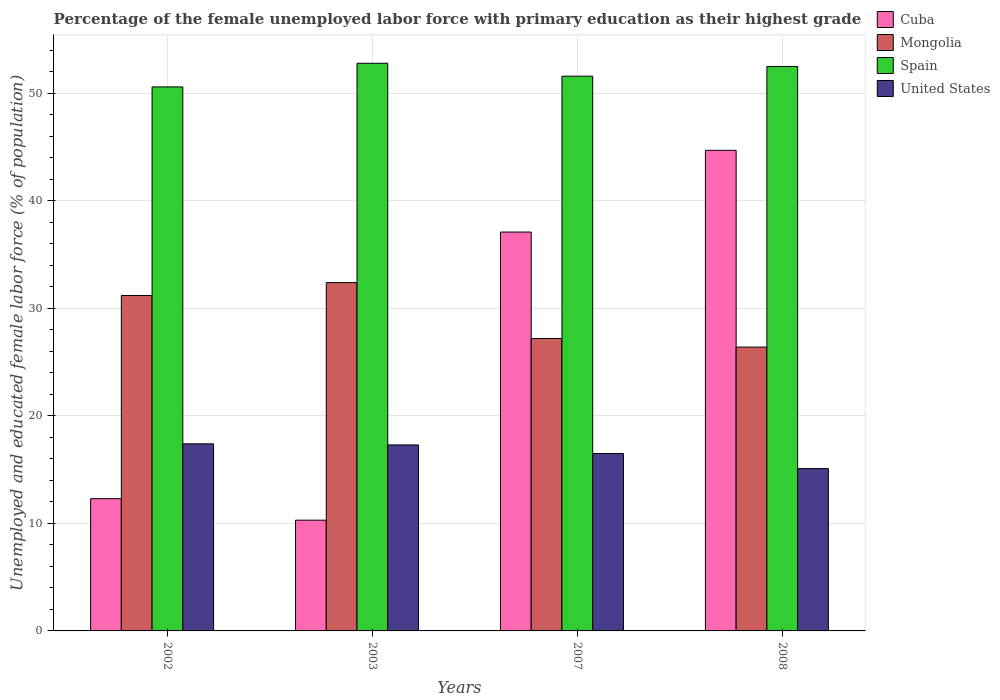How many different coloured bars are there?
Give a very brief answer. 4. How many bars are there on the 3rd tick from the left?
Offer a very short reply. 4. What is the label of the 1st group of bars from the left?
Provide a short and direct response. 2002. In how many cases, is the number of bars for a given year not equal to the number of legend labels?
Your answer should be compact. 0. What is the percentage of the unemployed female labor force with primary education in Spain in 2002?
Keep it short and to the point. 50.6. Across all years, what is the maximum percentage of the unemployed female labor force with primary education in Cuba?
Provide a succinct answer. 44.7. Across all years, what is the minimum percentage of the unemployed female labor force with primary education in Mongolia?
Give a very brief answer. 26.4. What is the total percentage of the unemployed female labor force with primary education in Mongolia in the graph?
Ensure brevity in your answer.  117.2. What is the difference between the percentage of the unemployed female labor force with primary education in United States in 2007 and that in 2008?
Ensure brevity in your answer.  1.4. What is the difference between the percentage of the unemployed female labor force with primary education in Mongolia in 2008 and the percentage of the unemployed female labor force with primary education in United States in 2007?
Make the answer very short. 9.9. What is the average percentage of the unemployed female labor force with primary education in United States per year?
Make the answer very short. 16.57. In the year 2002, what is the difference between the percentage of the unemployed female labor force with primary education in United States and percentage of the unemployed female labor force with primary education in Cuba?
Your response must be concise. 5.1. What is the ratio of the percentage of the unemployed female labor force with primary education in United States in 2002 to that in 2003?
Your response must be concise. 1.01. What is the difference between the highest and the second highest percentage of the unemployed female labor force with primary education in United States?
Offer a terse response. 0.1. What is the difference between the highest and the lowest percentage of the unemployed female labor force with primary education in Spain?
Your answer should be very brief. 2.2. In how many years, is the percentage of the unemployed female labor force with primary education in Spain greater than the average percentage of the unemployed female labor force with primary education in Spain taken over all years?
Keep it short and to the point. 2. What does the 3rd bar from the left in 2008 represents?
Give a very brief answer. Spain. Is it the case that in every year, the sum of the percentage of the unemployed female labor force with primary education in Spain and percentage of the unemployed female labor force with primary education in United States is greater than the percentage of the unemployed female labor force with primary education in Cuba?
Keep it short and to the point. Yes. Are all the bars in the graph horizontal?
Offer a terse response. No. What is the title of the graph?
Offer a terse response. Percentage of the female unemployed labor force with primary education as their highest grade. Does "Sub-Saharan Africa (developing only)" appear as one of the legend labels in the graph?
Offer a terse response. No. What is the label or title of the X-axis?
Give a very brief answer. Years. What is the label or title of the Y-axis?
Your answer should be very brief. Unemployed and educated female labor force (% of population). What is the Unemployed and educated female labor force (% of population) of Cuba in 2002?
Offer a terse response. 12.3. What is the Unemployed and educated female labor force (% of population) in Mongolia in 2002?
Offer a terse response. 31.2. What is the Unemployed and educated female labor force (% of population) in Spain in 2002?
Make the answer very short. 50.6. What is the Unemployed and educated female labor force (% of population) in United States in 2002?
Give a very brief answer. 17.4. What is the Unemployed and educated female labor force (% of population) of Cuba in 2003?
Offer a terse response. 10.3. What is the Unemployed and educated female labor force (% of population) in Mongolia in 2003?
Provide a succinct answer. 32.4. What is the Unemployed and educated female labor force (% of population) of Spain in 2003?
Ensure brevity in your answer.  52.8. What is the Unemployed and educated female labor force (% of population) of United States in 2003?
Provide a succinct answer. 17.3. What is the Unemployed and educated female labor force (% of population) of Cuba in 2007?
Provide a succinct answer. 37.1. What is the Unemployed and educated female labor force (% of population) in Mongolia in 2007?
Your answer should be very brief. 27.2. What is the Unemployed and educated female labor force (% of population) of Spain in 2007?
Offer a terse response. 51.6. What is the Unemployed and educated female labor force (% of population) in Cuba in 2008?
Offer a terse response. 44.7. What is the Unemployed and educated female labor force (% of population) of Mongolia in 2008?
Offer a very short reply. 26.4. What is the Unemployed and educated female labor force (% of population) of Spain in 2008?
Offer a terse response. 52.5. What is the Unemployed and educated female labor force (% of population) in United States in 2008?
Offer a very short reply. 15.1. Across all years, what is the maximum Unemployed and educated female labor force (% of population) of Cuba?
Your answer should be compact. 44.7. Across all years, what is the maximum Unemployed and educated female labor force (% of population) of Mongolia?
Provide a succinct answer. 32.4. Across all years, what is the maximum Unemployed and educated female labor force (% of population) in Spain?
Make the answer very short. 52.8. Across all years, what is the maximum Unemployed and educated female labor force (% of population) in United States?
Make the answer very short. 17.4. Across all years, what is the minimum Unemployed and educated female labor force (% of population) in Cuba?
Ensure brevity in your answer.  10.3. Across all years, what is the minimum Unemployed and educated female labor force (% of population) in Mongolia?
Make the answer very short. 26.4. Across all years, what is the minimum Unemployed and educated female labor force (% of population) in Spain?
Offer a very short reply. 50.6. Across all years, what is the minimum Unemployed and educated female labor force (% of population) of United States?
Offer a very short reply. 15.1. What is the total Unemployed and educated female labor force (% of population) of Cuba in the graph?
Keep it short and to the point. 104.4. What is the total Unemployed and educated female labor force (% of population) in Mongolia in the graph?
Your response must be concise. 117.2. What is the total Unemployed and educated female labor force (% of population) in Spain in the graph?
Your answer should be very brief. 207.5. What is the total Unemployed and educated female labor force (% of population) of United States in the graph?
Your answer should be compact. 66.3. What is the difference between the Unemployed and educated female labor force (% of population) of Mongolia in 2002 and that in 2003?
Offer a very short reply. -1.2. What is the difference between the Unemployed and educated female labor force (% of population) in Cuba in 2002 and that in 2007?
Your response must be concise. -24.8. What is the difference between the Unemployed and educated female labor force (% of population) in Mongolia in 2002 and that in 2007?
Your answer should be very brief. 4. What is the difference between the Unemployed and educated female labor force (% of population) of Spain in 2002 and that in 2007?
Ensure brevity in your answer.  -1. What is the difference between the Unemployed and educated female labor force (% of population) of United States in 2002 and that in 2007?
Your answer should be compact. 0.9. What is the difference between the Unemployed and educated female labor force (% of population) in Cuba in 2002 and that in 2008?
Your answer should be very brief. -32.4. What is the difference between the Unemployed and educated female labor force (% of population) in Spain in 2002 and that in 2008?
Keep it short and to the point. -1.9. What is the difference between the Unemployed and educated female labor force (% of population) in Cuba in 2003 and that in 2007?
Offer a terse response. -26.8. What is the difference between the Unemployed and educated female labor force (% of population) of Cuba in 2003 and that in 2008?
Make the answer very short. -34.4. What is the difference between the Unemployed and educated female labor force (% of population) of Mongolia in 2003 and that in 2008?
Offer a very short reply. 6. What is the difference between the Unemployed and educated female labor force (% of population) in Cuba in 2007 and that in 2008?
Keep it short and to the point. -7.6. What is the difference between the Unemployed and educated female labor force (% of population) in Mongolia in 2007 and that in 2008?
Your answer should be compact. 0.8. What is the difference between the Unemployed and educated female labor force (% of population) of Cuba in 2002 and the Unemployed and educated female labor force (% of population) of Mongolia in 2003?
Keep it short and to the point. -20.1. What is the difference between the Unemployed and educated female labor force (% of population) of Cuba in 2002 and the Unemployed and educated female labor force (% of population) of Spain in 2003?
Give a very brief answer. -40.5. What is the difference between the Unemployed and educated female labor force (% of population) of Mongolia in 2002 and the Unemployed and educated female labor force (% of population) of Spain in 2003?
Provide a succinct answer. -21.6. What is the difference between the Unemployed and educated female labor force (% of population) in Spain in 2002 and the Unemployed and educated female labor force (% of population) in United States in 2003?
Ensure brevity in your answer.  33.3. What is the difference between the Unemployed and educated female labor force (% of population) of Cuba in 2002 and the Unemployed and educated female labor force (% of population) of Mongolia in 2007?
Provide a short and direct response. -14.9. What is the difference between the Unemployed and educated female labor force (% of population) in Cuba in 2002 and the Unemployed and educated female labor force (% of population) in Spain in 2007?
Provide a succinct answer. -39.3. What is the difference between the Unemployed and educated female labor force (% of population) of Cuba in 2002 and the Unemployed and educated female labor force (% of population) of United States in 2007?
Ensure brevity in your answer.  -4.2. What is the difference between the Unemployed and educated female labor force (% of population) of Mongolia in 2002 and the Unemployed and educated female labor force (% of population) of Spain in 2007?
Keep it short and to the point. -20.4. What is the difference between the Unemployed and educated female labor force (% of population) of Spain in 2002 and the Unemployed and educated female labor force (% of population) of United States in 2007?
Offer a terse response. 34.1. What is the difference between the Unemployed and educated female labor force (% of population) in Cuba in 2002 and the Unemployed and educated female labor force (% of population) in Mongolia in 2008?
Your answer should be compact. -14.1. What is the difference between the Unemployed and educated female labor force (% of population) of Cuba in 2002 and the Unemployed and educated female labor force (% of population) of Spain in 2008?
Your response must be concise. -40.2. What is the difference between the Unemployed and educated female labor force (% of population) in Cuba in 2002 and the Unemployed and educated female labor force (% of population) in United States in 2008?
Your answer should be very brief. -2.8. What is the difference between the Unemployed and educated female labor force (% of population) of Mongolia in 2002 and the Unemployed and educated female labor force (% of population) of Spain in 2008?
Provide a succinct answer. -21.3. What is the difference between the Unemployed and educated female labor force (% of population) of Spain in 2002 and the Unemployed and educated female labor force (% of population) of United States in 2008?
Offer a very short reply. 35.5. What is the difference between the Unemployed and educated female labor force (% of population) in Cuba in 2003 and the Unemployed and educated female labor force (% of population) in Mongolia in 2007?
Offer a terse response. -16.9. What is the difference between the Unemployed and educated female labor force (% of population) of Cuba in 2003 and the Unemployed and educated female labor force (% of population) of Spain in 2007?
Provide a short and direct response. -41.3. What is the difference between the Unemployed and educated female labor force (% of population) of Cuba in 2003 and the Unemployed and educated female labor force (% of population) of United States in 2007?
Give a very brief answer. -6.2. What is the difference between the Unemployed and educated female labor force (% of population) of Mongolia in 2003 and the Unemployed and educated female labor force (% of population) of Spain in 2007?
Offer a terse response. -19.2. What is the difference between the Unemployed and educated female labor force (% of population) in Mongolia in 2003 and the Unemployed and educated female labor force (% of population) in United States in 2007?
Offer a very short reply. 15.9. What is the difference between the Unemployed and educated female labor force (% of population) in Spain in 2003 and the Unemployed and educated female labor force (% of population) in United States in 2007?
Offer a very short reply. 36.3. What is the difference between the Unemployed and educated female labor force (% of population) in Cuba in 2003 and the Unemployed and educated female labor force (% of population) in Mongolia in 2008?
Keep it short and to the point. -16.1. What is the difference between the Unemployed and educated female labor force (% of population) of Cuba in 2003 and the Unemployed and educated female labor force (% of population) of Spain in 2008?
Provide a short and direct response. -42.2. What is the difference between the Unemployed and educated female labor force (% of population) of Cuba in 2003 and the Unemployed and educated female labor force (% of population) of United States in 2008?
Make the answer very short. -4.8. What is the difference between the Unemployed and educated female labor force (% of population) of Mongolia in 2003 and the Unemployed and educated female labor force (% of population) of Spain in 2008?
Offer a very short reply. -20.1. What is the difference between the Unemployed and educated female labor force (% of population) of Spain in 2003 and the Unemployed and educated female labor force (% of population) of United States in 2008?
Keep it short and to the point. 37.7. What is the difference between the Unemployed and educated female labor force (% of population) of Cuba in 2007 and the Unemployed and educated female labor force (% of population) of Mongolia in 2008?
Offer a terse response. 10.7. What is the difference between the Unemployed and educated female labor force (% of population) of Cuba in 2007 and the Unemployed and educated female labor force (% of population) of Spain in 2008?
Give a very brief answer. -15.4. What is the difference between the Unemployed and educated female labor force (% of population) in Cuba in 2007 and the Unemployed and educated female labor force (% of population) in United States in 2008?
Keep it short and to the point. 22. What is the difference between the Unemployed and educated female labor force (% of population) in Mongolia in 2007 and the Unemployed and educated female labor force (% of population) in Spain in 2008?
Ensure brevity in your answer.  -25.3. What is the difference between the Unemployed and educated female labor force (% of population) in Mongolia in 2007 and the Unemployed and educated female labor force (% of population) in United States in 2008?
Keep it short and to the point. 12.1. What is the difference between the Unemployed and educated female labor force (% of population) of Spain in 2007 and the Unemployed and educated female labor force (% of population) of United States in 2008?
Your answer should be very brief. 36.5. What is the average Unemployed and educated female labor force (% of population) of Cuba per year?
Offer a very short reply. 26.1. What is the average Unemployed and educated female labor force (% of population) in Mongolia per year?
Offer a terse response. 29.3. What is the average Unemployed and educated female labor force (% of population) of Spain per year?
Keep it short and to the point. 51.88. What is the average Unemployed and educated female labor force (% of population) in United States per year?
Ensure brevity in your answer.  16.57. In the year 2002, what is the difference between the Unemployed and educated female labor force (% of population) of Cuba and Unemployed and educated female labor force (% of population) of Mongolia?
Your response must be concise. -18.9. In the year 2002, what is the difference between the Unemployed and educated female labor force (% of population) of Cuba and Unemployed and educated female labor force (% of population) of Spain?
Give a very brief answer. -38.3. In the year 2002, what is the difference between the Unemployed and educated female labor force (% of population) in Mongolia and Unemployed and educated female labor force (% of population) in Spain?
Offer a terse response. -19.4. In the year 2002, what is the difference between the Unemployed and educated female labor force (% of population) of Spain and Unemployed and educated female labor force (% of population) of United States?
Offer a very short reply. 33.2. In the year 2003, what is the difference between the Unemployed and educated female labor force (% of population) of Cuba and Unemployed and educated female labor force (% of population) of Mongolia?
Provide a succinct answer. -22.1. In the year 2003, what is the difference between the Unemployed and educated female labor force (% of population) in Cuba and Unemployed and educated female labor force (% of population) in Spain?
Offer a terse response. -42.5. In the year 2003, what is the difference between the Unemployed and educated female labor force (% of population) in Mongolia and Unemployed and educated female labor force (% of population) in Spain?
Give a very brief answer. -20.4. In the year 2003, what is the difference between the Unemployed and educated female labor force (% of population) of Spain and Unemployed and educated female labor force (% of population) of United States?
Provide a short and direct response. 35.5. In the year 2007, what is the difference between the Unemployed and educated female labor force (% of population) of Cuba and Unemployed and educated female labor force (% of population) of Mongolia?
Provide a short and direct response. 9.9. In the year 2007, what is the difference between the Unemployed and educated female labor force (% of population) in Cuba and Unemployed and educated female labor force (% of population) in United States?
Give a very brief answer. 20.6. In the year 2007, what is the difference between the Unemployed and educated female labor force (% of population) in Mongolia and Unemployed and educated female labor force (% of population) in Spain?
Offer a very short reply. -24.4. In the year 2007, what is the difference between the Unemployed and educated female labor force (% of population) in Spain and Unemployed and educated female labor force (% of population) in United States?
Give a very brief answer. 35.1. In the year 2008, what is the difference between the Unemployed and educated female labor force (% of population) in Cuba and Unemployed and educated female labor force (% of population) in Spain?
Provide a short and direct response. -7.8. In the year 2008, what is the difference between the Unemployed and educated female labor force (% of population) of Cuba and Unemployed and educated female labor force (% of population) of United States?
Make the answer very short. 29.6. In the year 2008, what is the difference between the Unemployed and educated female labor force (% of population) of Mongolia and Unemployed and educated female labor force (% of population) of Spain?
Offer a terse response. -26.1. In the year 2008, what is the difference between the Unemployed and educated female labor force (% of population) of Spain and Unemployed and educated female labor force (% of population) of United States?
Your answer should be very brief. 37.4. What is the ratio of the Unemployed and educated female labor force (% of population) in Cuba in 2002 to that in 2003?
Keep it short and to the point. 1.19. What is the ratio of the Unemployed and educated female labor force (% of population) in Spain in 2002 to that in 2003?
Give a very brief answer. 0.96. What is the ratio of the Unemployed and educated female labor force (% of population) in Cuba in 2002 to that in 2007?
Give a very brief answer. 0.33. What is the ratio of the Unemployed and educated female labor force (% of population) of Mongolia in 2002 to that in 2007?
Provide a succinct answer. 1.15. What is the ratio of the Unemployed and educated female labor force (% of population) in Spain in 2002 to that in 2007?
Make the answer very short. 0.98. What is the ratio of the Unemployed and educated female labor force (% of population) of United States in 2002 to that in 2007?
Offer a very short reply. 1.05. What is the ratio of the Unemployed and educated female labor force (% of population) in Cuba in 2002 to that in 2008?
Your response must be concise. 0.28. What is the ratio of the Unemployed and educated female labor force (% of population) in Mongolia in 2002 to that in 2008?
Your answer should be very brief. 1.18. What is the ratio of the Unemployed and educated female labor force (% of population) in Spain in 2002 to that in 2008?
Your response must be concise. 0.96. What is the ratio of the Unemployed and educated female labor force (% of population) in United States in 2002 to that in 2008?
Provide a short and direct response. 1.15. What is the ratio of the Unemployed and educated female labor force (% of population) of Cuba in 2003 to that in 2007?
Offer a terse response. 0.28. What is the ratio of the Unemployed and educated female labor force (% of population) in Mongolia in 2003 to that in 2007?
Ensure brevity in your answer.  1.19. What is the ratio of the Unemployed and educated female labor force (% of population) in Spain in 2003 to that in 2007?
Give a very brief answer. 1.02. What is the ratio of the Unemployed and educated female labor force (% of population) of United States in 2003 to that in 2007?
Offer a very short reply. 1.05. What is the ratio of the Unemployed and educated female labor force (% of population) in Cuba in 2003 to that in 2008?
Your answer should be compact. 0.23. What is the ratio of the Unemployed and educated female labor force (% of population) in Mongolia in 2003 to that in 2008?
Offer a terse response. 1.23. What is the ratio of the Unemployed and educated female labor force (% of population) of United States in 2003 to that in 2008?
Offer a terse response. 1.15. What is the ratio of the Unemployed and educated female labor force (% of population) in Cuba in 2007 to that in 2008?
Your response must be concise. 0.83. What is the ratio of the Unemployed and educated female labor force (% of population) in Mongolia in 2007 to that in 2008?
Keep it short and to the point. 1.03. What is the ratio of the Unemployed and educated female labor force (% of population) in Spain in 2007 to that in 2008?
Your response must be concise. 0.98. What is the ratio of the Unemployed and educated female labor force (% of population) in United States in 2007 to that in 2008?
Offer a terse response. 1.09. What is the difference between the highest and the second highest Unemployed and educated female labor force (% of population) of Cuba?
Ensure brevity in your answer.  7.6. What is the difference between the highest and the second highest Unemployed and educated female labor force (% of population) of Mongolia?
Provide a short and direct response. 1.2. What is the difference between the highest and the second highest Unemployed and educated female labor force (% of population) of Spain?
Your answer should be compact. 0.3. What is the difference between the highest and the second highest Unemployed and educated female labor force (% of population) of United States?
Offer a very short reply. 0.1. What is the difference between the highest and the lowest Unemployed and educated female labor force (% of population) in Cuba?
Your answer should be very brief. 34.4. 